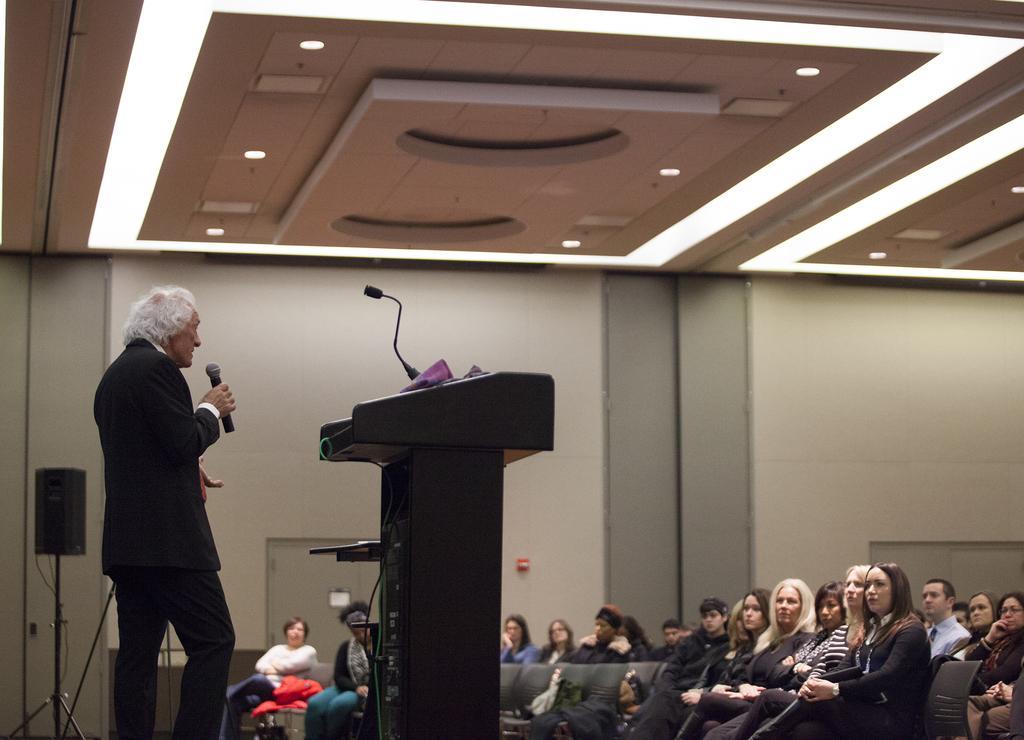How would you summarize this image in a sentence or two? In this image on the left side there is one person who is standing and he is holding a mike it seems that he is talking. In front of him there is one podium and mike, and on the right side at the bottom there are some people who are sitting on chairs. In the background there is a wall, speaker, pole and wires and also there are two doors. On the top there is ceiling and some lights. 